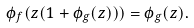Convert formula to latex. <formula><loc_0><loc_0><loc_500><loc_500>\phi _ { f } ( z ( 1 + \phi _ { g } ( z ) ) ) = \phi _ { g } ( z ) .</formula> 